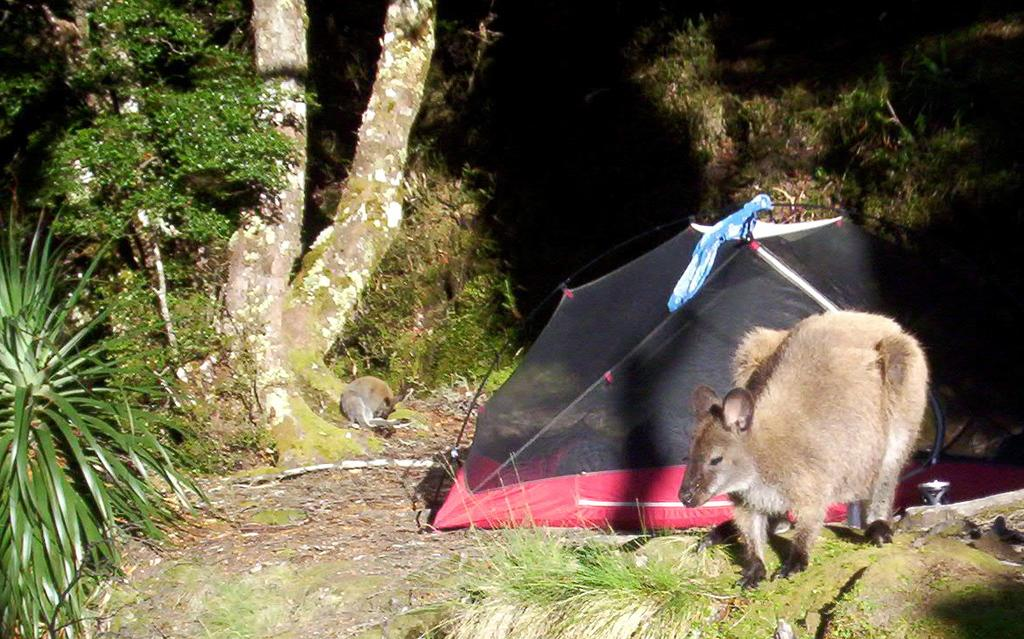What type of animal is in the image? There is a wallaby in the image. What can be seen in the background of the image? There are trees visible in the image. What type of shelter is on the ground in the image? There is a tent on the ground in the image. What type of mark can be seen on the wallaby's fur in the image? There is no mark visible on the wallaby's fur in the image. Are there any tomatoes growing on the trees in the image? There are no tomatoes present in the image; only trees are visible. Can you see a harbor in the image? There is no harbor present in the image. 